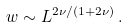<formula> <loc_0><loc_0><loc_500><loc_500>w \sim L ^ { 2 \nu / ( 1 + 2 \nu ) } \, .</formula> 